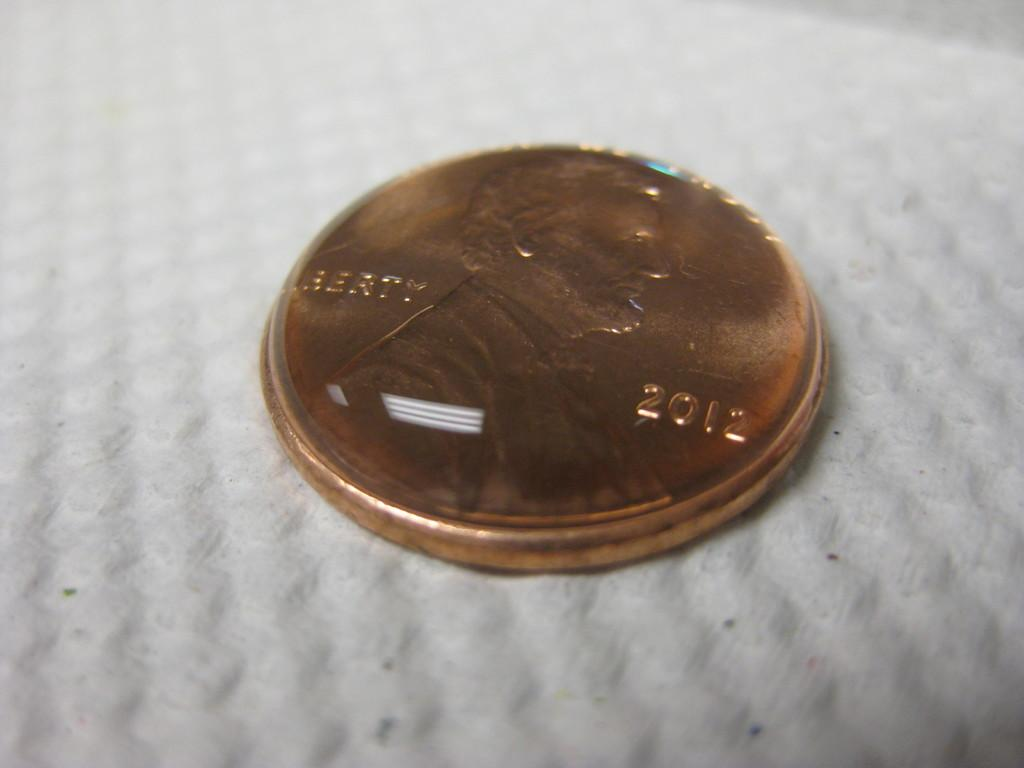<image>
Describe the image concisely. Liberty 2012 is stamped onto the face of this coin. 